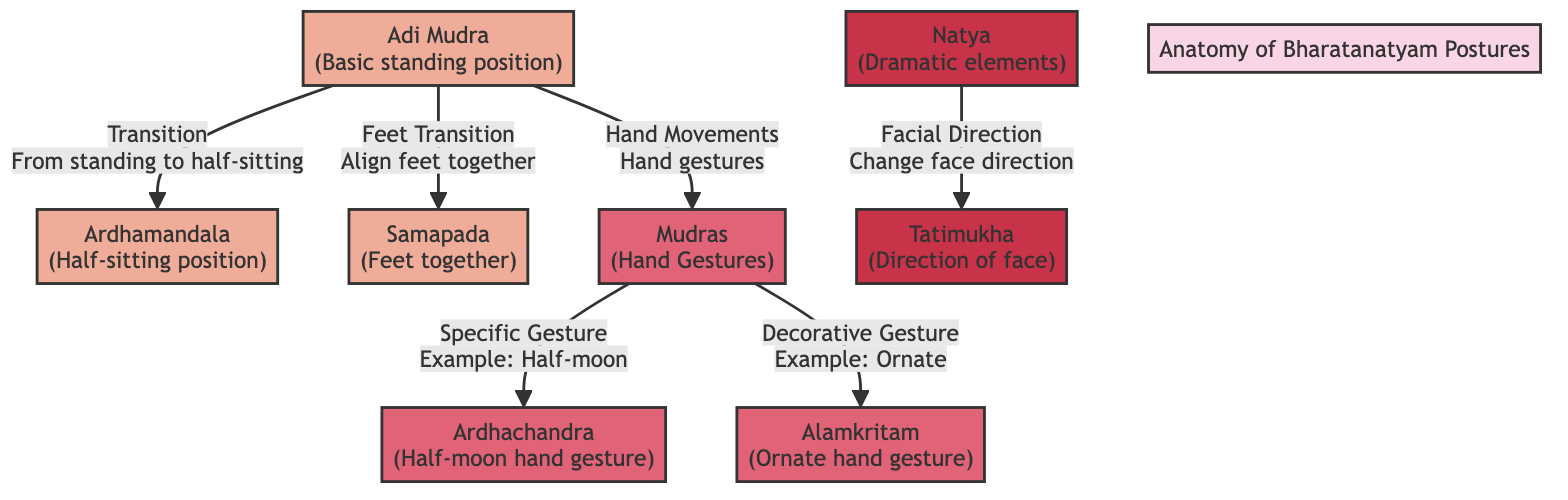What is the starting position in Bharatanatyam postures? The diagram indicates "Adi Mudra" as the starting position in Bharatanatyam postures, illustrated as the first node in the flowchart.
Answer: Adi Mudra How many main postures are shown in the diagram? The diagram consists of three main postures: "Adi Mudra," "Ardhamandala," and "Samapada." Counting these nodes gives a total of three.
Answer: 3 What is the outcome of the transition from Adi Mudra to Ardhamandala? The diagram specifies that the transition from "Adi Mudra" leads to "Ardhamandala," which is defined as the "Half-sitting position." Thus, it illustrates this transformation.
Answer: Half-sitting position Which gesture represents the "Half-moon hand gesture"? "Ardhachandra" is identified in the diagram as the specific gesture representing the "Half-moon hand gesture." This is clearly marked in the node linked to "Mudras."
Answer: Ardhachandra What do the dramatic elements in the diagram include? The diagram lists "Natya" as the term encompassing the dramatic elements, highlighting its significance in Bharatanatyam postures.
Answer: Natya What gesture is an example of a decorative hand movement? The diagram specifies "Alamkritam" as the illustrative example of a decorative gesture, emphasizing its role in the category of hand gestures.
Answer: Alamkritam From which posture do both hand gesture transitions originate? The diagram indicates that both transitions concerning hand movements originate from the "Mudras" node, which itself connects back to "Adi Mudra."
Answer: Mudras Which node is associated with the direction of facial change? The diagram points to "Tatimukha" as the node that details the aspect of facial direction change within the Bharatanatyam postures.
Answer: Tatimukha What is the relationship between Mudras and hand movements? Mudras are shown as a direct relation to hand movements, indicating that they are specifically categorized under this aspect of Bharatanatyam, leading to specific gestures like "Ardhachandra" and "Alamkritam."
Answer: Hand movements 